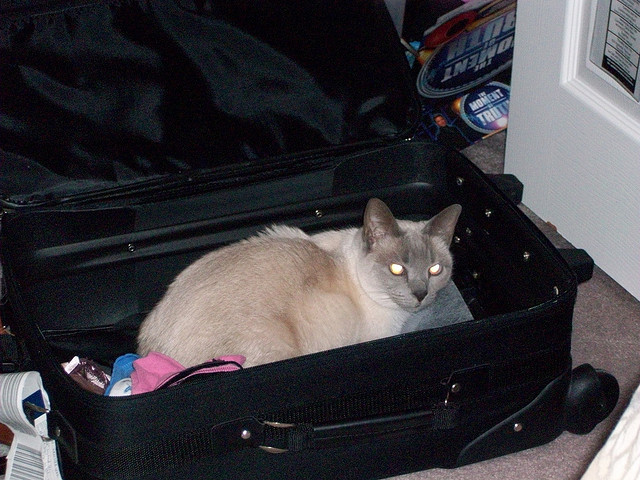Please transcribe the text information in this image. MOMENT TRUTH 